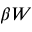<formula> <loc_0><loc_0><loc_500><loc_500>\beta W</formula> 